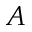Convert formula to latex. <formula><loc_0><loc_0><loc_500><loc_500>A</formula> 